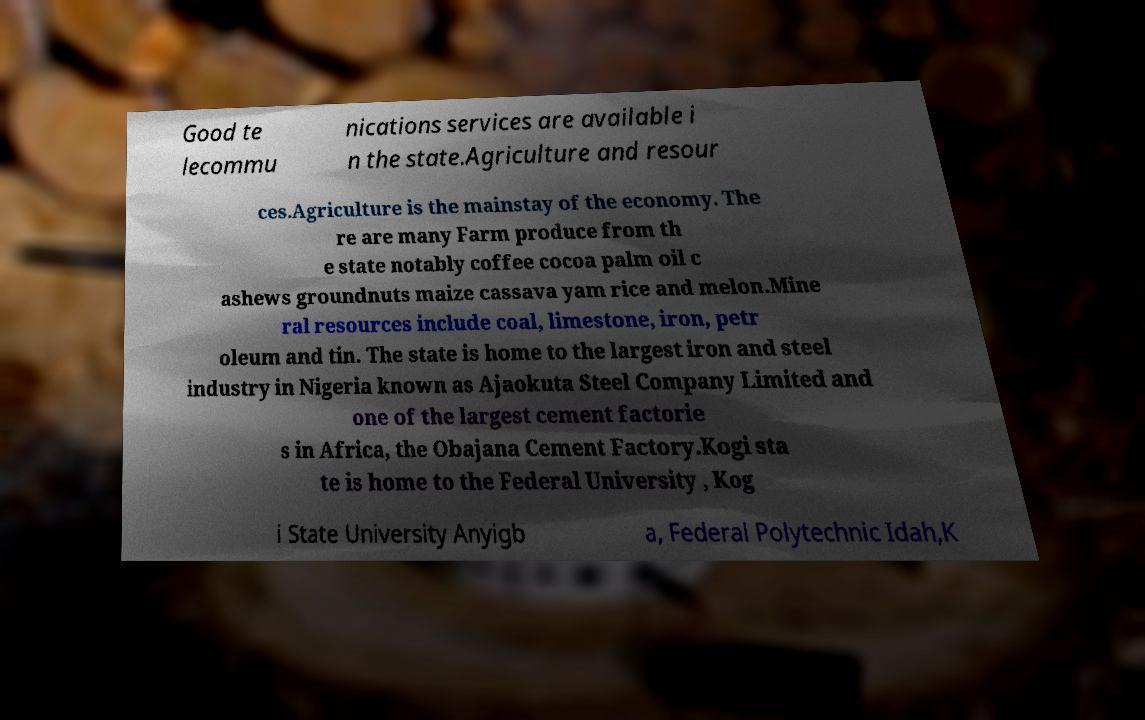For documentation purposes, I need the text within this image transcribed. Could you provide that? Good te lecommu nications services are available i n the state.Agriculture and resour ces.Agriculture is the mainstay of the economy. The re are many Farm produce from th e state notably coffee cocoa palm oil c ashews groundnuts maize cassava yam rice and melon.Mine ral resources include coal, limestone, iron, petr oleum and tin. The state is home to the largest iron and steel industry in Nigeria known as Ajaokuta Steel Company Limited and one of the largest cement factorie s in Africa, the Obajana Cement Factory.Kogi sta te is home to the Federal University , Kog i State University Anyigb a, Federal Polytechnic Idah,K 